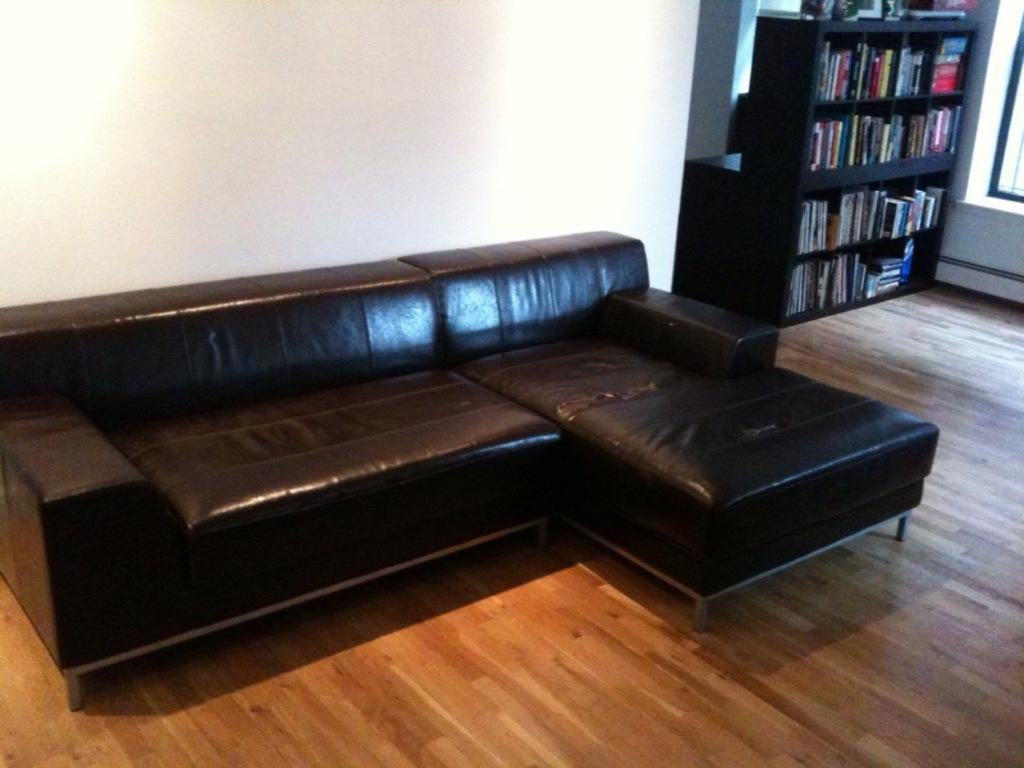Where was the image taken? The image was taken in a room. What type of flooring is present in the room? There is a wooden floor in the room. What piece of furniture is on the wooden floor? There is a black color sofa on the floor. What color is the wall behind the sofa? The background of the sofa is a white wall. What can be seen in the background of the image? There is a shelf in the background. What items are on the shelf? There are books on the shelf. How many worms can be seen crawling on the wooden floor in the image? There are no worms present in the image; it only shows a black color sofa on a wooden floor with a white wall and a shelf with books in the background. 